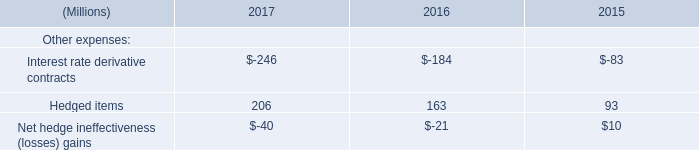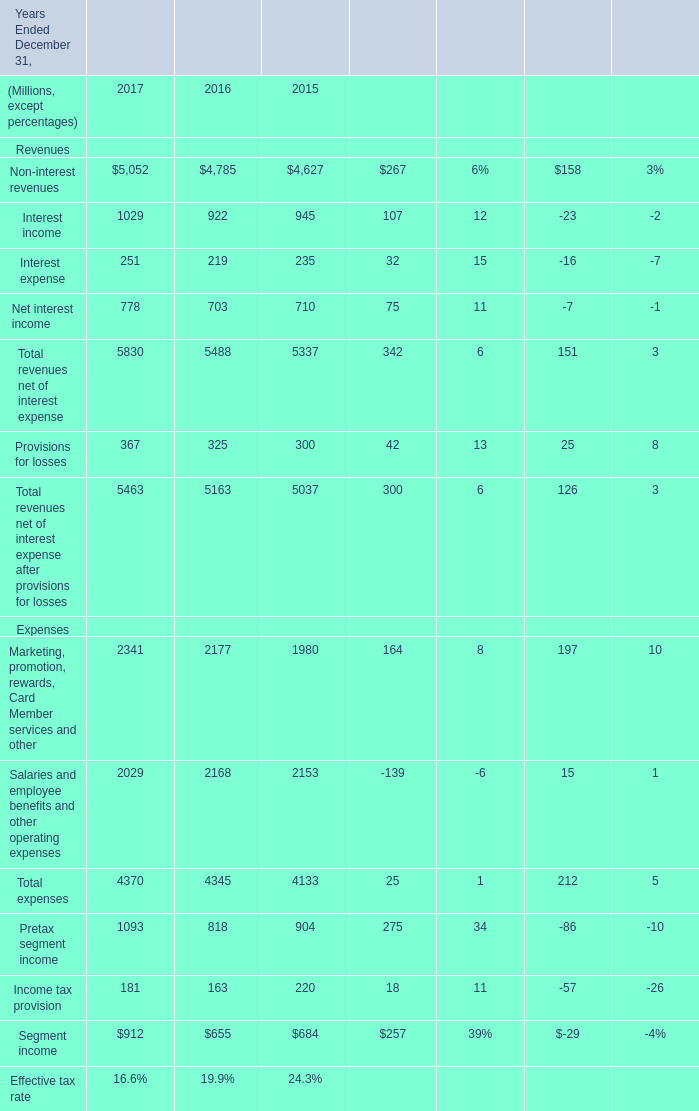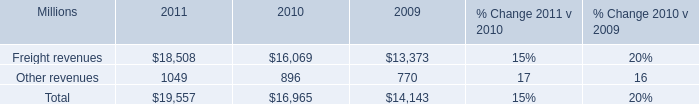In the year with the most Pretax segment income, what is the growth rate of interest expense? 
Computations: ((5830 - 5488) / 5488)
Answer: 0.06232. 